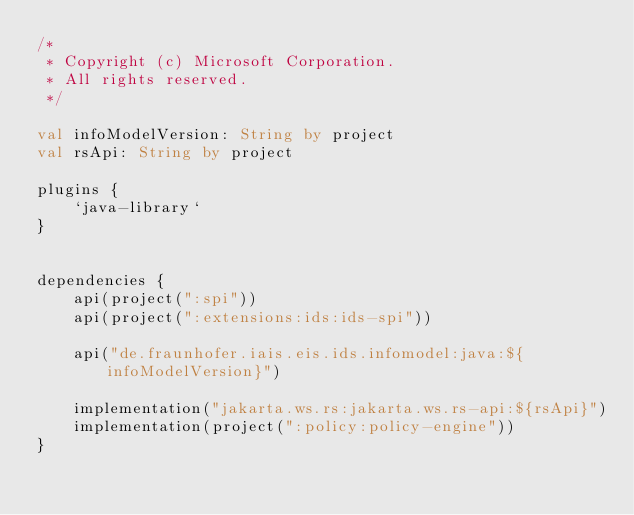Convert code to text. <code><loc_0><loc_0><loc_500><loc_500><_Kotlin_>/*
 * Copyright (c) Microsoft Corporation.
 * All rights reserved.
 */

val infoModelVersion: String by project
val rsApi: String by project

plugins {
    `java-library`
}


dependencies {
    api(project(":spi"))
    api(project(":extensions:ids:ids-spi"))

    api("de.fraunhofer.iais.eis.ids.infomodel:java:${infoModelVersion}")
    
    implementation("jakarta.ws.rs:jakarta.ws.rs-api:${rsApi}")
    implementation(project(":policy:policy-engine"))
}


</code> 